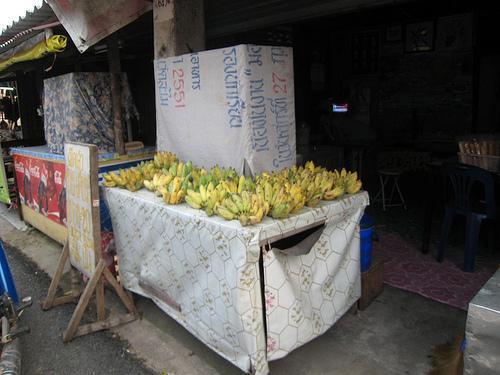How many tables are in the picture?
Give a very brief answer. 2. 